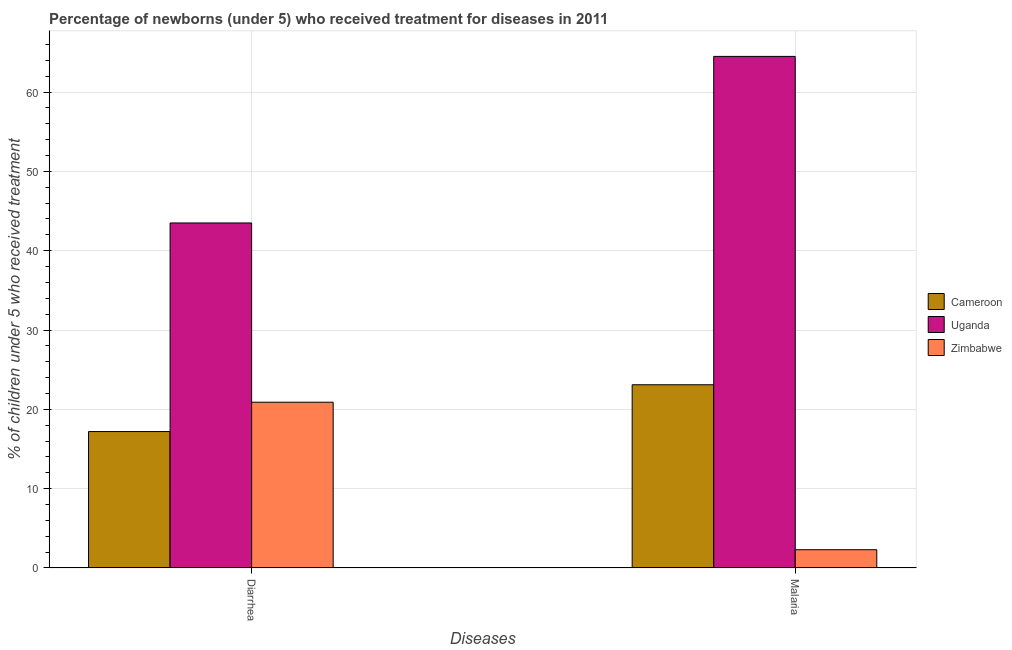How many groups of bars are there?
Your answer should be compact. 2. Are the number of bars per tick equal to the number of legend labels?
Your answer should be compact. Yes. Are the number of bars on each tick of the X-axis equal?
Make the answer very short. Yes. How many bars are there on the 2nd tick from the left?
Offer a terse response. 3. What is the label of the 1st group of bars from the left?
Your response must be concise. Diarrhea. Across all countries, what is the maximum percentage of children who received treatment for malaria?
Your answer should be compact. 64.5. In which country was the percentage of children who received treatment for malaria maximum?
Keep it short and to the point. Uganda. In which country was the percentage of children who received treatment for diarrhoea minimum?
Your response must be concise. Cameroon. What is the total percentage of children who received treatment for malaria in the graph?
Your answer should be compact. 89.9. What is the difference between the percentage of children who received treatment for malaria in Cameroon and that in Uganda?
Offer a terse response. -41.4. What is the difference between the percentage of children who received treatment for malaria in Uganda and the percentage of children who received treatment for diarrhoea in Zimbabwe?
Provide a short and direct response. 43.6. What is the average percentage of children who received treatment for malaria per country?
Keep it short and to the point. 29.97. What is the difference between the percentage of children who received treatment for diarrhoea and percentage of children who received treatment for malaria in Zimbabwe?
Your answer should be compact. 18.6. In how many countries, is the percentage of children who received treatment for diarrhoea greater than 32 %?
Make the answer very short. 1. What is the ratio of the percentage of children who received treatment for diarrhoea in Cameroon to that in Zimbabwe?
Offer a terse response. 0.82. What does the 2nd bar from the left in Malaria represents?
Provide a succinct answer. Uganda. What does the 3rd bar from the right in Diarrhea represents?
Your answer should be very brief. Cameroon. How many countries are there in the graph?
Provide a succinct answer. 3. Are the values on the major ticks of Y-axis written in scientific E-notation?
Offer a very short reply. No. Does the graph contain any zero values?
Offer a very short reply. No. How are the legend labels stacked?
Make the answer very short. Vertical. What is the title of the graph?
Give a very brief answer. Percentage of newborns (under 5) who received treatment for diseases in 2011. Does "Greece" appear as one of the legend labels in the graph?
Provide a short and direct response. No. What is the label or title of the X-axis?
Your answer should be compact. Diseases. What is the label or title of the Y-axis?
Provide a short and direct response. % of children under 5 who received treatment. What is the % of children under 5 who received treatment in Cameroon in Diarrhea?
Your answer should be compact. 17.2. What is the % of children under 5 who received treatment of Uganda in Diarrhea?
Keep it short and to the point. 43.5. What is the % of children under 5 who received treatment of Zimbabwe in Diarrhea?
Provide a short and direct response. 20.9. What is the % of children under 5 who received treatment in Cameroon in Malaria?
Your answer should be compact. 23.1. What is the % of children under 5 who received treatment of Uganda in Malaria?
Your answer should be compact. 64.5. Across all Diseases, what is the maximum % of children under 5 who received treatment of Cameroon?
Offer a very short reply. 23.1. Across all Diseases, what is the maximum % of children under 5 who received treatment in Uganda?
Provide a succinct answer. 64.5. Across all Diseases, what is the maximum % of children under 5 who received treatment in Zimbabwe?
Make the answer very short. 20.9. Across all Diseases, what is the minimum % of children under 5 who received treatment of Uganda?
Your response must be concise. 43.5. What is the total % of children under 5 who received treatment of Cameroon in the graph?
Offer a very short reply. 40.3. What is the total % of children under 5 who received treatment of Uganda in the graph?
Make the answer very short. 108. What is the total % of children under 5 who received treatment in Zimbabwe in the graph?
Offer a very short reply. 23.2. What is the difference between the % of children under 5 who received treatment in Cameroon in Diarrhea and that in Malaria?
Provide a short and direct response. -5.9. What is the difference between the % of children under 5 who received treatment of Uganda in Diarrhea and that in Malaria?
Offer a terse response. -21. What is the difference between the % of children under 5 who received treatment of Cameroon in Diarrhea and the % of children under 5 who received treatment of Uganda in Malaria?
Give a very brief answer. -47.3. What is the difference between the % of children under 5 who received treatment in Cameroon in Diarrhea and the % of children under 5 who received treatment in Zimbabwe in Malaria?
Offer a terse response. 14.9. What is the difference between the % of children under 5 who received treatment of Uganda in Diarrhea and the % of children under 5 who received treatment of Zimbabwe in Malaria?
Your answer should be very brief. 41.2. What is the average % of children under 5 who received treatment in Cameroon per Diseases?
Your answer should be very brief. 20.15. What is the average % of children under 5 who received treatment of Uganda per Diseases?
Your response must be concise. 54. What is the average % of children under 5 who received treatment of Zimbabwe per Diseases?
Your answer should be compact. 11.6. What is the difference between the % of children under 5 who received treatment in Cameroon and % of children under 5 who received treatment in Uganda in Diarrhea?
Ensure brevity in your answer.  -26.3. What is the difference between the % of children under 5 who received treatment in Uganda and % of children under 5 who received treatment in Zimbabwe in Diarrhea?
Make the answer very short. 22.6. What is the difference between the % of children under 5 who received treatment in Cameroon and % of children under 5 who received treatment in Uganda in Malaria?
Provide a short and direct response. -41.4. What is the difference between the % of children under 5 who received treatment in Cameroon and % of children under 5 who received treatment in Zimbabwe in Malaria?
Provide a succinct answer. 20.8. What is the difference between the % of children under 5 who received treatment of Uganda and % of children under 5 who received treatment of Zimbabwe in Malaria?
Provide a succinct answer. 62.2. What is the ratio of the % of children under 5 who received treatment in Cameroon in Diarrhea to that in Malaria?
Your response must be concise. 0.74. What is the ratio of the % of children under 5 who received treatment of Uganda in Diarrhea to that in Malaria?
Give a very brief answer. 0.67. What is the ratio of the % of children under 5 who received treatment of Zimbabwe in Diarrhea to that in Malaria?
Ensure brevity in your answer.  9.09. What is the difference between the highest and the second highest % of children under 5 who received treatment of Cameroon?
Make the answer very short. 5.9. What is the difference between the highest and the second highest % of children under 5 who received treatment of Uganda?
Keep it short and to the point. 21. What is the difference between the highest and the lowest % of children under 5 who received treatment of Uganda?
Offer a terse response. 21. What is the difference between the highest and the lowest % of children under 5 who received treatment of Zimbabwe?
Your answer should be compact. 18.6. 